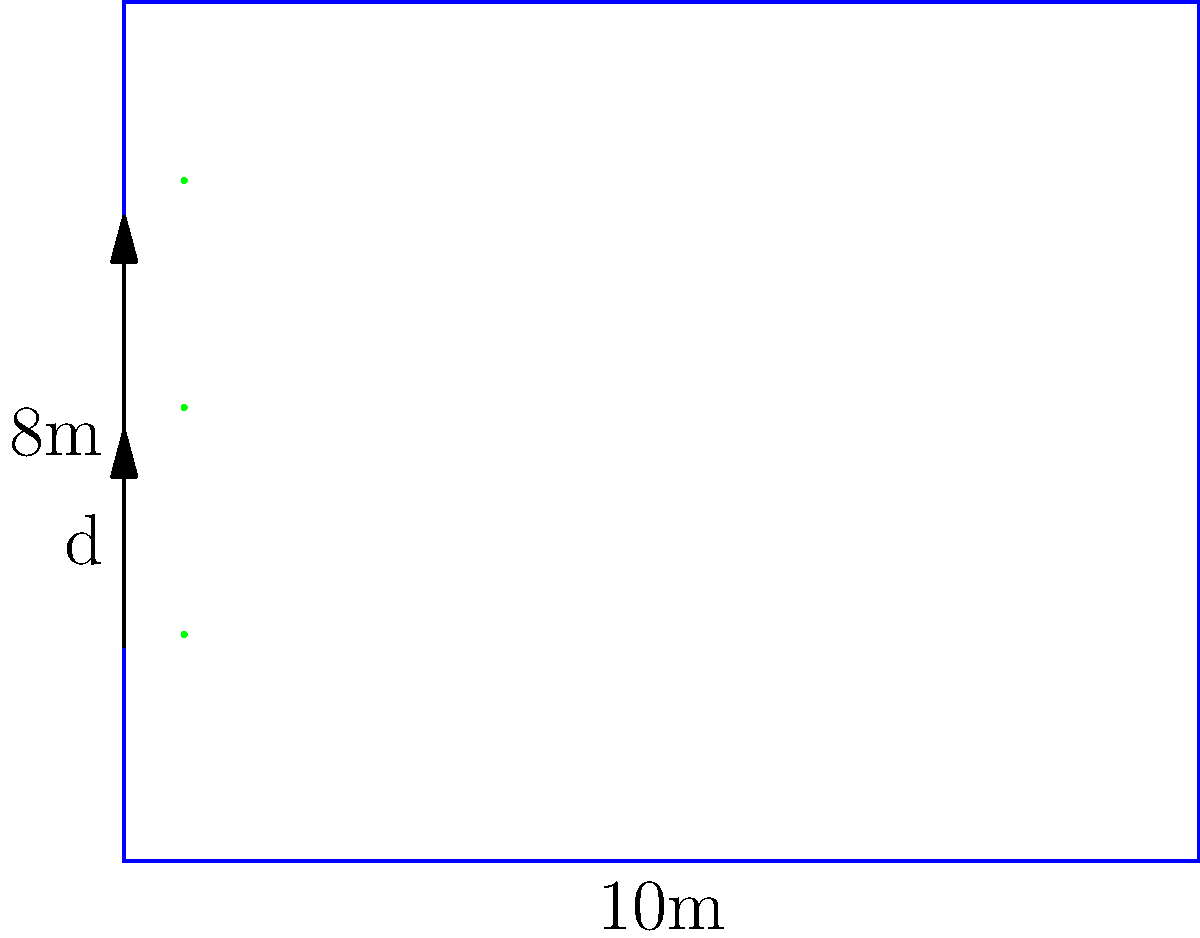In a rectangular field measuring 10m by 8m, you plan to plant three equally spaced rows of botanicals. What is the optimal spacing (d) between the rows to maximize the number of plants while ensuring adequate growth space? To find the optimal spacing between rows, we need to follow these steps:

1. Understand the field dimensions:
   - Width = 10m
   - Height = 8m

2. Calculate the number of spaces:
   - With 3 rows, there are 4 spaces (2 edge spaces and 2 between rows)

3. Calculate the spacing:
   - Total height = 8m
   - Number of spaces = 4
   - Spacing (d) = Total height / Number of spaces
   - $d = 8m / 4 = 2m$

4. Verify the result:
   - Bottom edge to first row: 2m
   - First row to second row: 2m
   - Second row to third row: 2m
   - Third row to top edge: 2m
   - Total: $2m + 2m + 2m + 2m = 8m$ (matches field height)

This spacing ensures equal distribution of the rows, maximizing the number of plants while providing adequate growth space for each row.
Answer: $d = 2m$ 